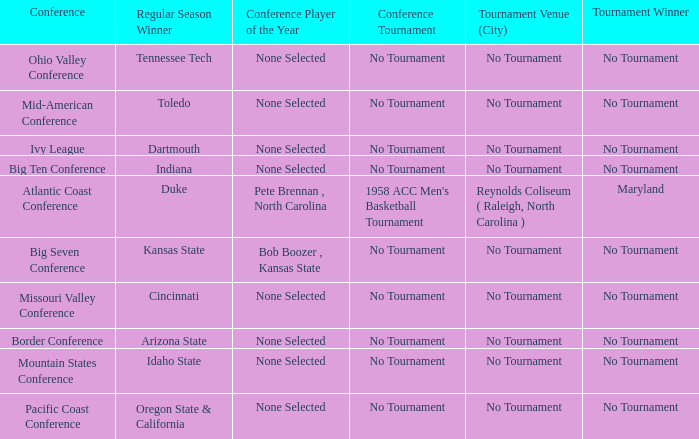When idaho state claimed victory in the regular season, who emerged as the tournament winner? No Tournament. 